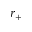<formula> <loc_0><loc_0><loc_500><loc_500>r _ { + }</formula> 